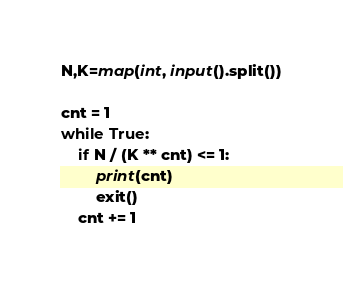Convert code to text. <code><loc_0><loc_0><loc_500><loc_500><_Python_>N,K=map(int, input().split())

cnt = 1
while True:
    if N / (K ** cnt) <= 1:
        print(cnt)
        exit()
    cnt += 1
</code> 